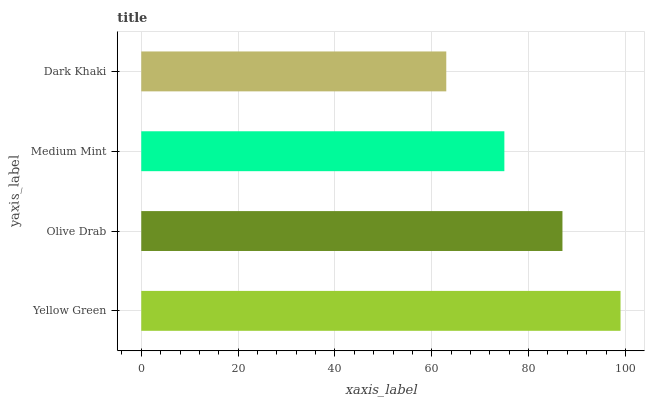Is Dark Khaki the minimum?
Answer yes or no. Yes. Is Yellow Green the maximum?
Answer yes or no. Yes. Is Olive Drab the minimum?
Answer yes or no. No. Is Olive Drab the maximum?
Answer yes or no. No. Is Yellow Green greater than Olive Drab?
Answer yes or no. Yes. Is Olive Drab less than Yellow Green?
Answer yes or no. Yes. Is Olive Drab greater than Yellow Green?
Answer yes or no. No. Is Yellow Green less than Olive Drab?
Answer yes or no. No. Is Olive Drab the high median?
Answer yes or no. Yes. Is Medium Mint the low median?
Answer yes or no. Yes. Is Medium Mint the high median?
Answer yes or no. No. Is Olive Drab the low median?
Answer yes or no. No. 